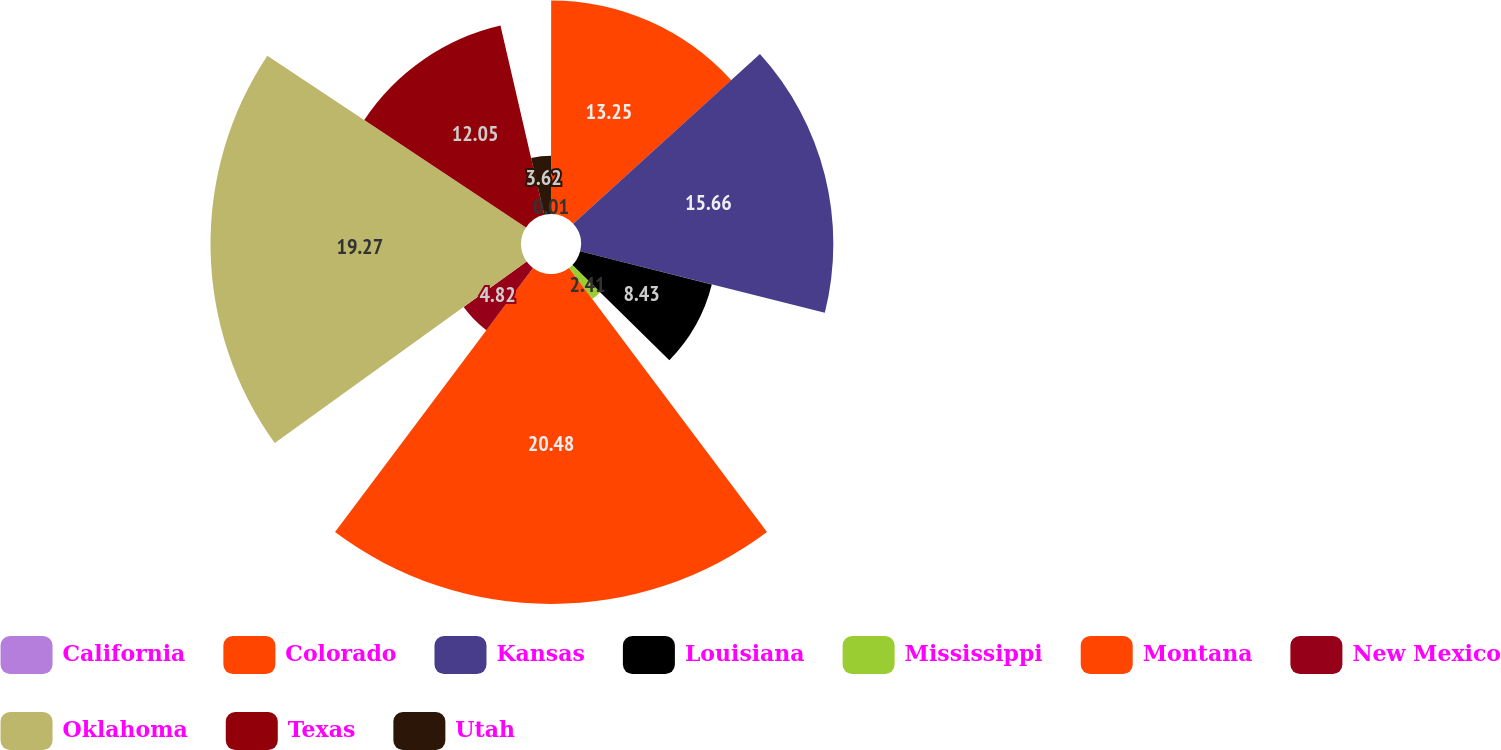Convert chart. <chart><loc_0><loc_0><loc_500><loc_500><pie_chart><fcel>California<fcel>Colorado<fcel>Kansas<fcel>Louisiana<fcel>Mississippi<fcel>Montana<fcel>New Mexico<fcel>Oklahoma<fcel>Texas<fcel>Utah<nl><fcel>0.01%<fcel>13.25%<fcel>15.66%<fcel>8.43%<fcel>2.41%<fcel>20.48%<fcel>4.82%<fcel>19.27%<fcel>12.05%<fcel>3.62%<nl></chart> 